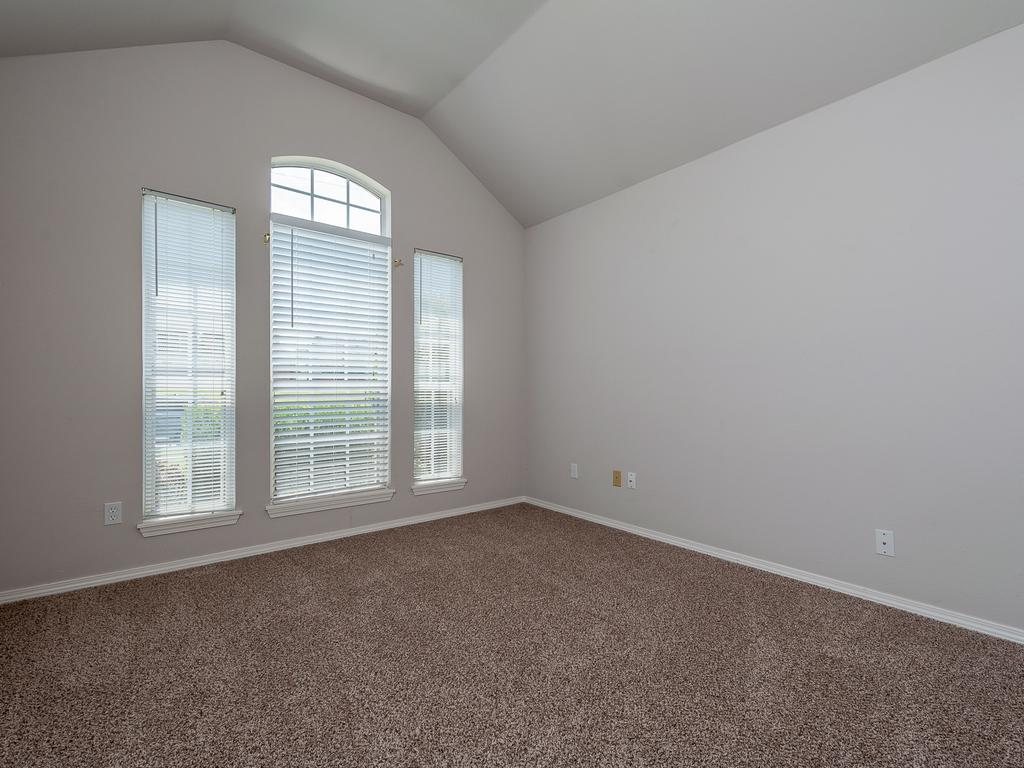What type of space is depicted in the image? The image shows an inside view of a room. What feature can be seen on the windows in the room? The windows in the room have window blinds. What surrounds the room? There are walls in the room. How many balloons are floating in the room in the image? There are no balloons present in the image. What type of company is conducting a meeting in the room in the image? There is no meeting or company depicted in the image; it shows an inside view of a room with windows and window blinds. 